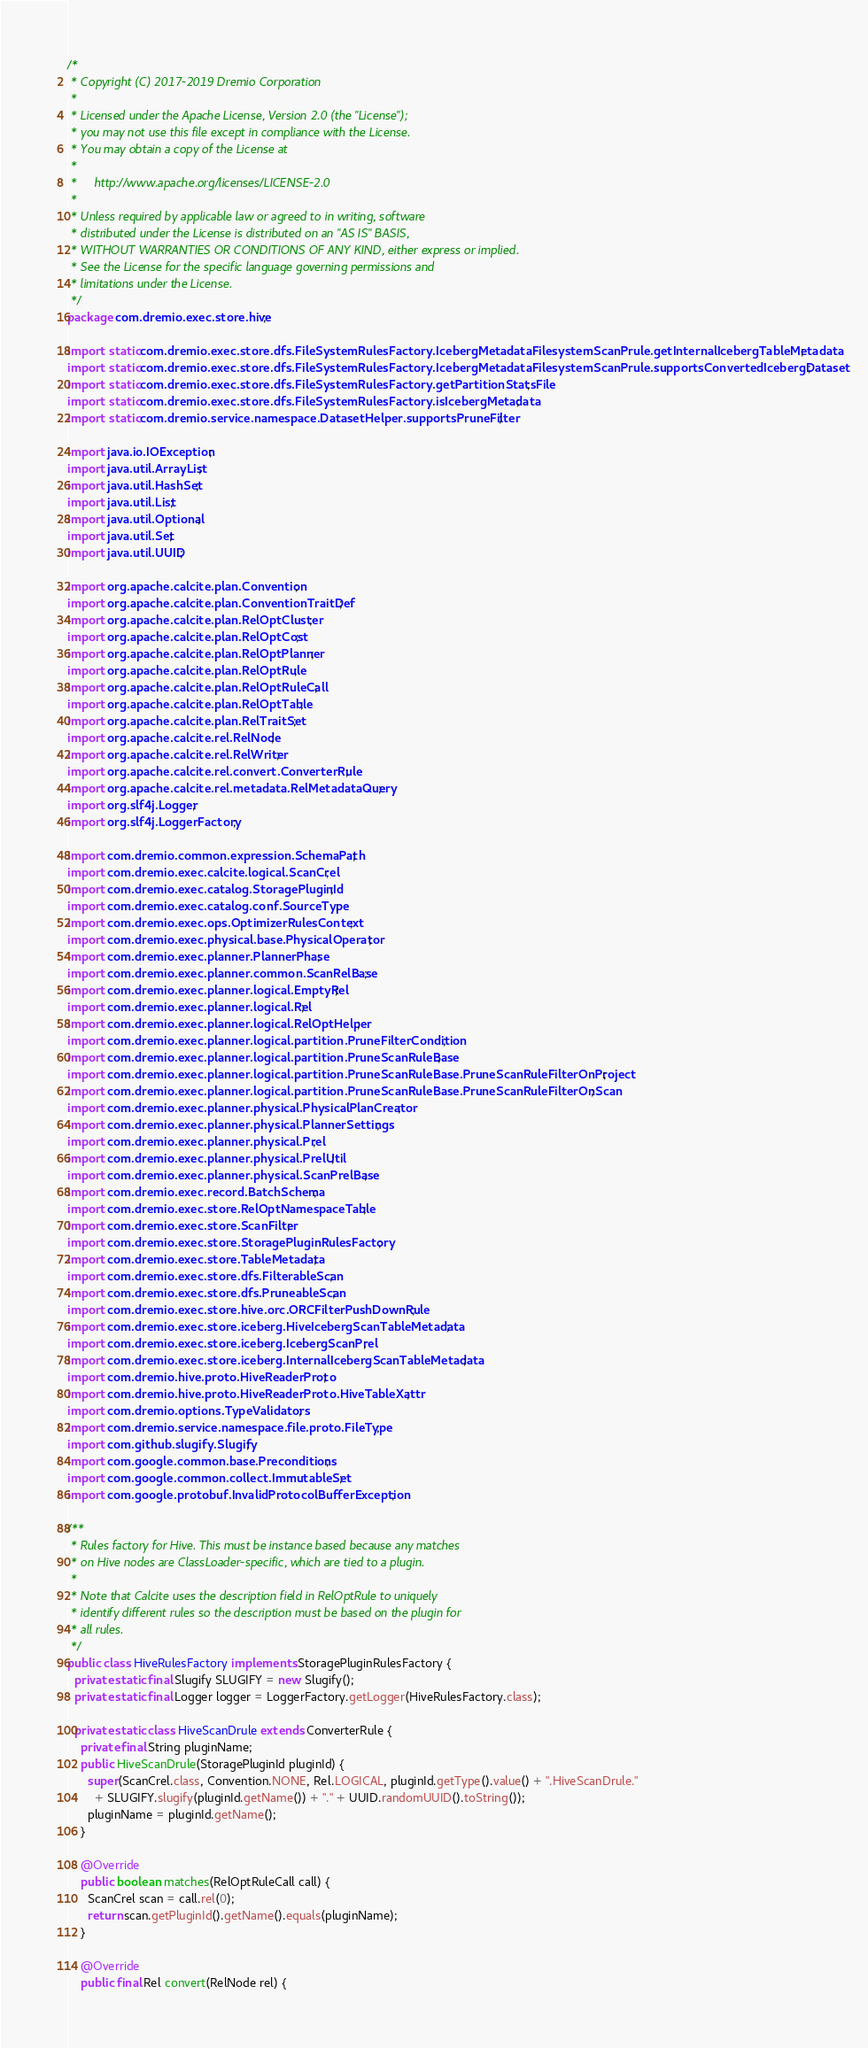Convert code to text. <code><loc_0><loc_0><loc_500><loc_500><_Java_>/*
 * Copyright (C) 2017-2019 Dremio Corporation
 *
 * Licensed under the Apache License, Version 2.0 (the "License");
 * you may not use this file except in compliance with the License.
 * You may obtain a copy of the License at
 *
 *     http://www.apache.org/licenses/LICENSE-2.0
 *
 * Unless required by applicable law or agreed to in writing, software
 * distributed under the License is distributed on an "AS IS" BASIS,
 * WITHOUT WARRANTIES OR CONDITIONS OF ANY KIND, either express or implied.
 * See the License for the specific language governing permissions and
 * limitations under the License.
 */
package com.dremio.exec.store.hive;

import static com.dremio.exec.store.dfs.FileSystemRulesFactory.IcebergMetadataFilesystemScanPrule.getInternalIcebergTableMetadata;
import static com.dremio.exec.store.dfs.FileSystemRulesFactory.IcebergMetadataFilesystemScanPrule.supportsConvertedIcebergDataset;
import static com.dremio.exec.store.dfs.FileSystemRulesFactory.getPartitionStatsFile;
import static com.dremio.exec.store.dfs.FileSystemRulesFactory.isIcebergMetadata;
import static com.dremio.service.namespace.DatasetHelper.supportsPruneFilter;

import java.io.IOException;
import java.util.ArrayList;
import java.util.HashSet;
import java.util.List;
import java.util.Optional;
import java.util.Set;
import java.util.UUID;

import org.apache.calcite.plan.Convention;
import org.apache.calcite.plan.ConventionTraitDef;
import org.apache.calcite.plan.RelOptCluster;
import org.apache.calcite.plan.RelOptCost;
import org.apache.calcite.plan.RelOptPlanner;
import org.apache.calcite.plan.RelOptRule;
import org.apache.calcite.plan.RelOptRuleCall;
import org.apache.calcite.plan.RelOptTable;
import org.apache.calcite.plan.RelTraitSet;
import org.apache.calcite.rel.RelNode;
import org.apache.calcite.rel.RelWriter;
import org.apache.calcite.rel.convert.ConverterRule;
import org.apache.calcite.rel.metadata.RelMetadataQuery;
import org.slf4j.Logger;
import org.slf4j.LoggerFactory;

import com.dremio.common.expression.SchemaPath;
import com.dremio.exec.calcite.logical.ScanCrel;
import com.dremio.exec.catalog.StoragePluginId;
import com.dremio.exec.catalog.conf.SourceType;
import com.dremio.exec.ops.OptimizerRulesContext;
import com.dremio.exec.physical.base.PhysicalOperator;
import com.dremio.exec.planner.PlannerPhase;
import com.dremio.exec.planner.common.ScanRelBase;
import com.dremio.exec.planner.logical.EmptyRel;
import com.dremio.exec.planner.logical.Rel;
import com.dremio.exec.planner.logical.RelOptHelper;
import com.dremio.exec.planner.logical.partition.PruneFilterCondition;
import com.dremio.exec.planner.logical.partition.PruneScanRuleBase;
import com.dremio.exec.planner.logical.partition.PruneScanRuleBase.PruneScanRuleFilterOnProject;
import com.dremio.exec.planner.logical.partition.PruneScanRuleBase.PruneScanRuleFilterOnScan;
import com.dremio.exec.planner.physical.PhysicalPlanCreator;
import com.dremio.exec.planner.physical.PlannerSettings;
import com.dremio.exec.planner.physical.Prel;
import com.dremio.exec.planner.physical.PrelUtil;
import com.dremio.exec.planner.physical.ScanPrelBase;
import com.dremio.exec.record.BatchSchema;
import com.dremio.exec.store.RelOptNamespaceTable;
import com.dremio.exec.store.ScanFilter;
import com.dremio.exec.store.StoragePluginRulesFactory;
import com.dremio.exec.store.TableMetadata;
import com.dremio.exec.store.dfs.FilterableScan;
import com.dremio.exec.store.dfs.PruneableScan;
import com.dremio.exec.store.hive.orc.ORCFilterPushDownRule;
import com.dremio.exec.store.iceberg.HiveIcebergScanTableMetadata;
import com.dremio.exec.store.iceberg.IcebergScanPrel;
import com.dremio.exec.store.iceberg.InternalIcebergScanTableMetadata;
import com.dremio.hive.proto.HiveReaderProto;
import com.dremio.hive.proto.HiveReaderProto.HiveTableXattr;
import com.dremio.options.TypeValidators;
import com.dremio.service.namespace.file.proto.FileType;
import com.github.slugify.Slugify;
import com.google.common.base.Preconditions;
import com.google.common.collect.ImmutableSet;
import com.google.protobuf.InvalidProtocolBufferException;

/**
 * Rules factory for Hive. This must be instance based because any matches
 * on Hive nodes are ClassLoader-specific, which are tied to a plugin.
 *
 * Note that Calcite uses the description field in RelOptRule to uniquely
 * identify different rules so the description must be based on the plugin for
 * all rules.
 */
public class HiveRulesFactory implements StoragePluginRulesFactory {
  private static final Slugify SLUGIFY = new Slugify();
  private static final Logger logger = LoggerFactory.getLogger(HiveRulesFactory.class);

  private static class HiveScanDrule extends ConverterRule {
    private final String pluginName;
    public HiveScanDrule(StoragePluginId pluginId) {
      super(ScanCrel.class, Convention.NONE, Rel.LOGICAL, pluginId.getType().value() + ".HiveScanDrule."
        + SLUGIFY.slugify(pluginId.getName()) + "." + UUID.randomUUID().toString());
      pluginName = pluginId.getName();
    }

    @Override
    public boolean matches(RelOptRuleCall call) {
      ScanCrel scan = call.rel(0);
      return scan.getPluginId().getName().equals(pluginName);
    }

    @Override
    public final Rel convert(RelNode rel) {</code> 